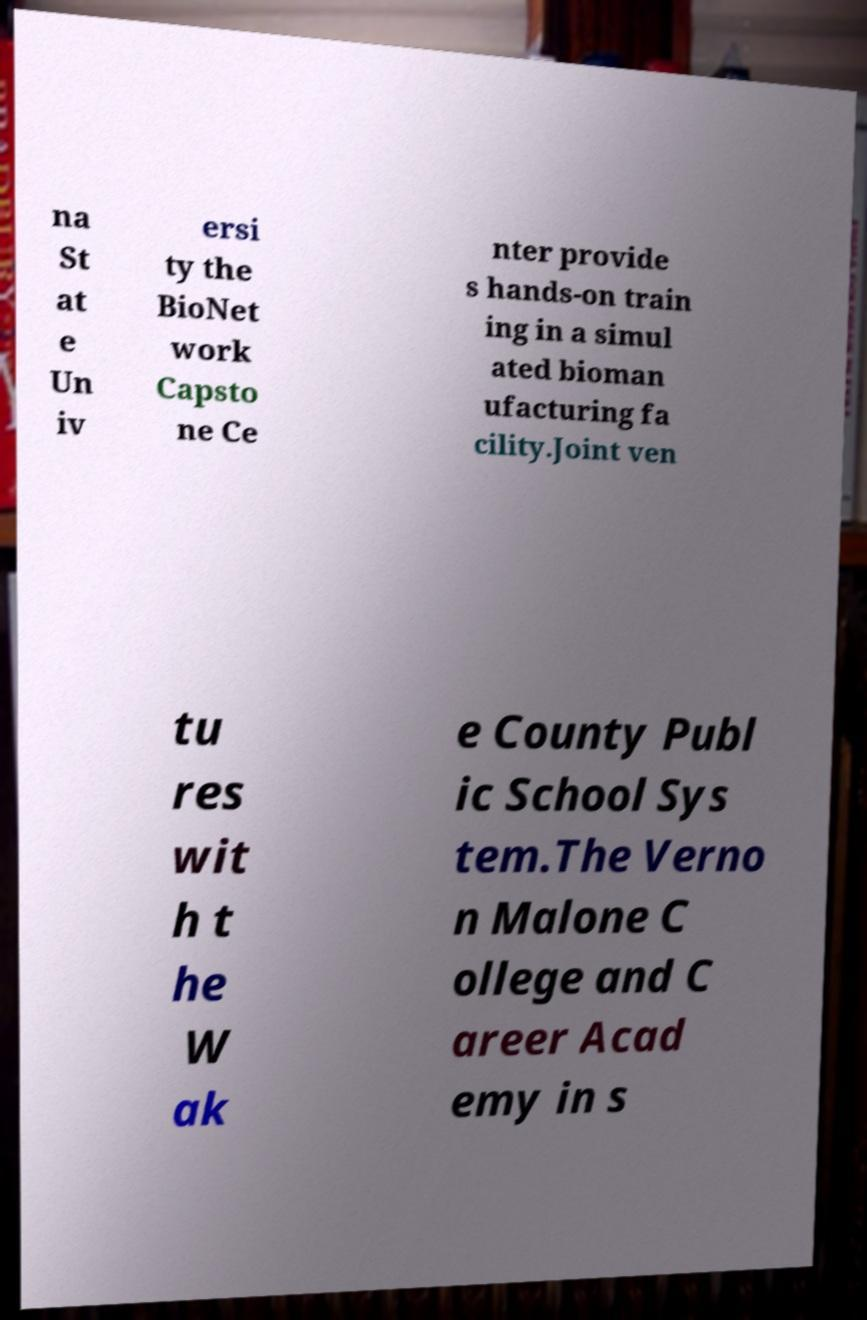There's text embedded in this image that I need extracted. Can you transcribe it verbatim? na St at e Un iv ersi ty the BioNet work Capsto ne Ce nter provide s hands-on train ing in a simul ated bioman ufacturing fa cility.Joint ven tu res wit h t he W ak e County Publ ic School Sys tem.The Verno n Malone C ollege and C areer Acad emy in s 